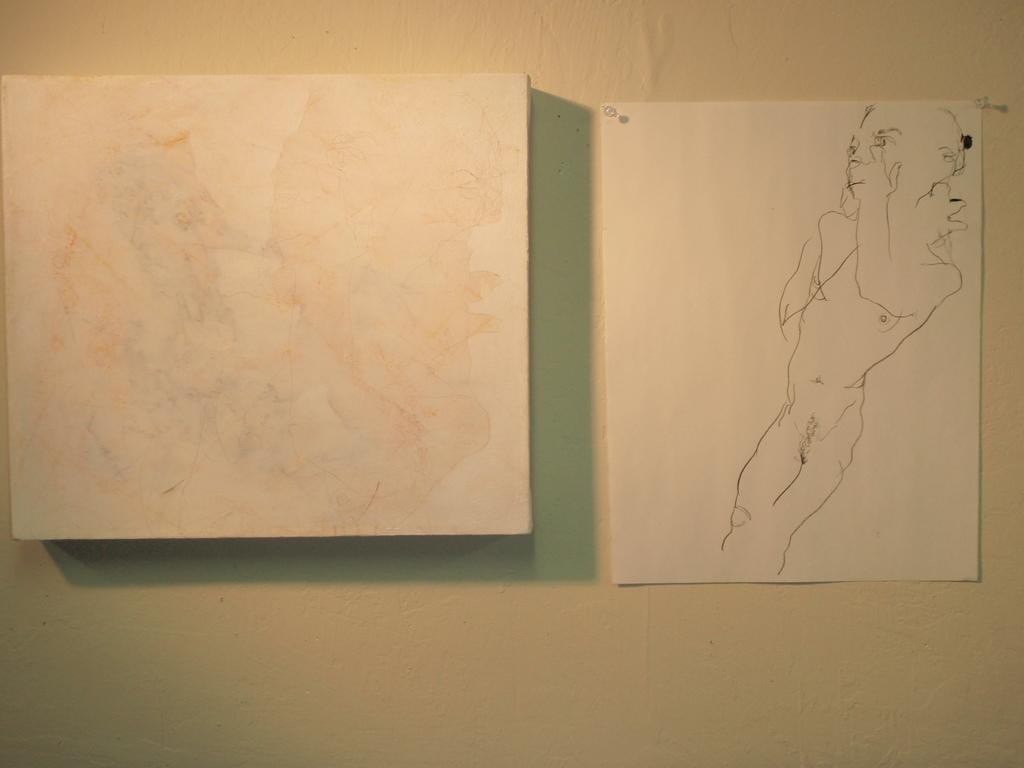What is one of the main features of the image? There is a wall in the image. What is placed on the wall? There is a paper in the image. What can be seen on the paper? There is a drawing on the paper. How many arches can be seen in the drawing on the paper? There is no mention of arches in the image or the drawing on the paper. 